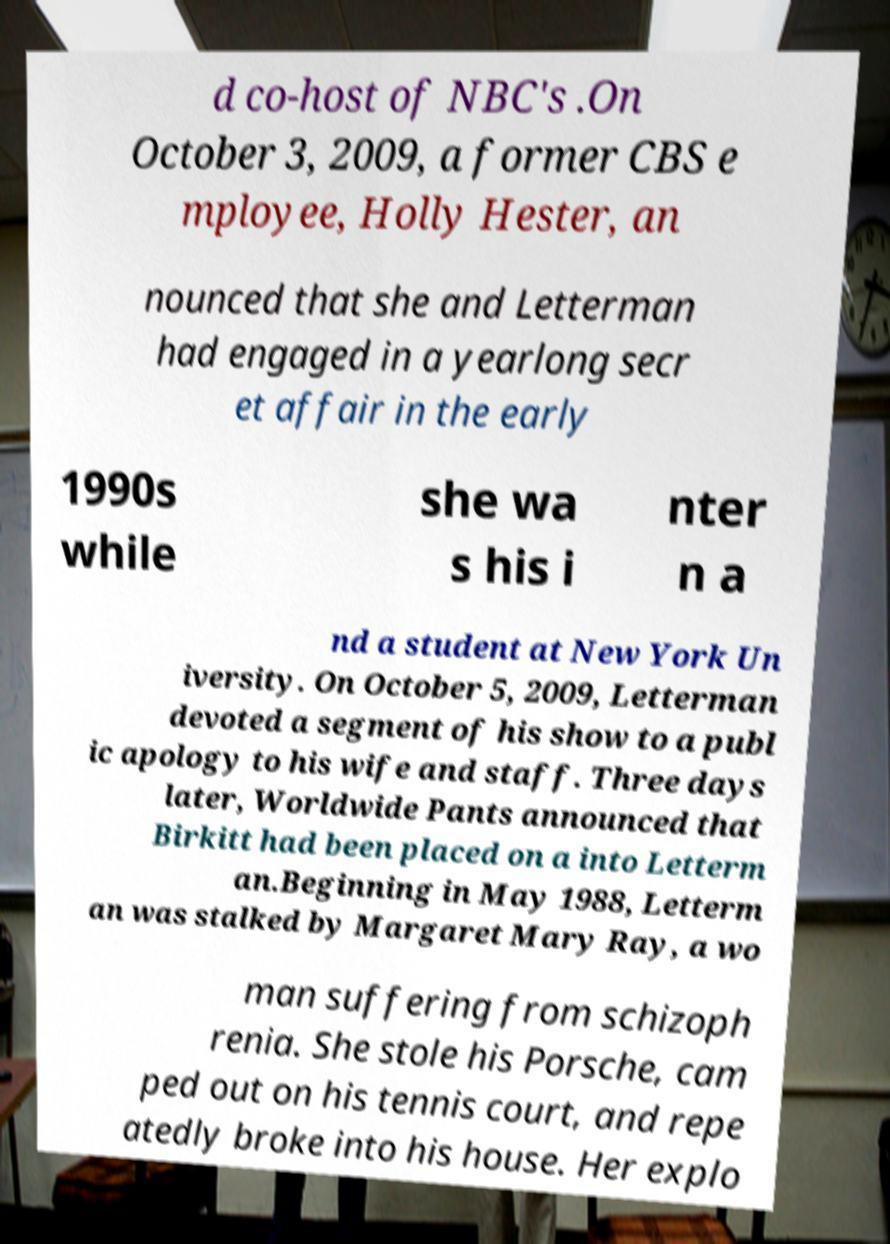Please identify and transcribe the text found in this image. d co-host of NBC's .On October 3, 2009, a former CBS e mployee, Holly Hester, an nounced that she and Letterman had engaged in a yearlong secr et affair in the early 1990s while she wa s his i nter n a nd a student at New York Un iversity. On October 5, 2009, Letterman devoted a segment of his show to a publ ic apology to his wife and staff. Three days later, Worldwide Pants announced that Birkitt had been placed on a into Letterm an.Beginning in May 1988, Letterm an was stalked by Margaret Mary Ray, a wo man suffering from schizoph renia. She stole his Porsche, cam ped out on his tennis court, and repe atedly broke into his house. Her explo 